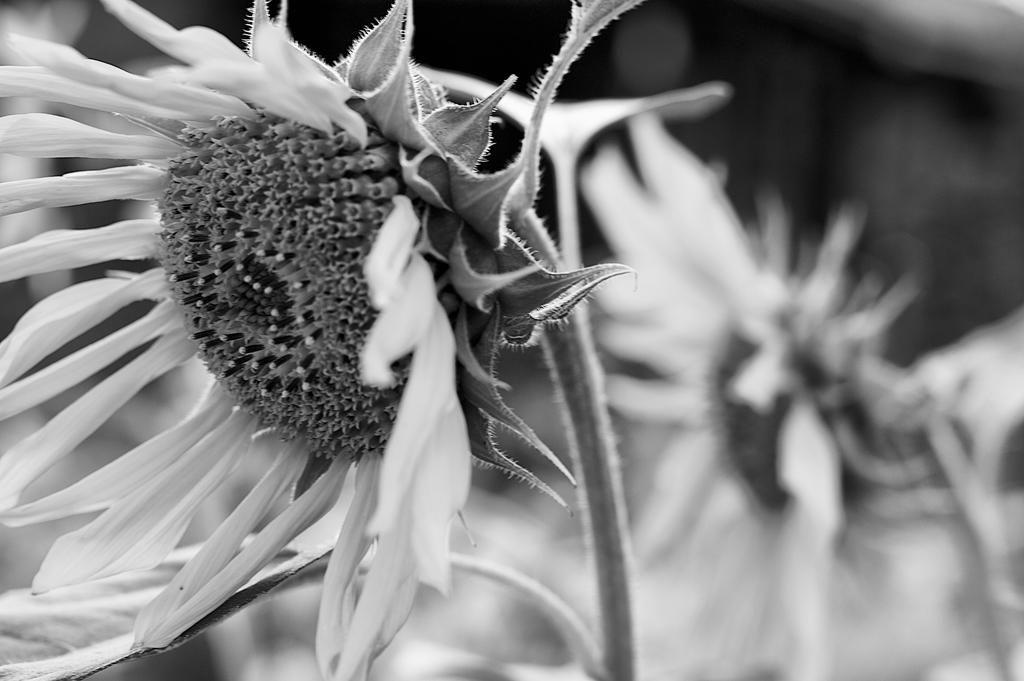What is the color scheme of the image? The image is black and white. What type of flora can be seen in the image? There are flowers in the image. Can you describe the background of the image? The background of the image is blurred. How many times has the ball been folded in the image? There is no ball present in the image, so it cannot be folded or have any folds. 